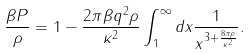<formula> <loc_0><loc_0><loc_500><loc_500>\frac { \beta P } { \rho } = 1 - \frac { 2 \pi \beta q ^ { 2 } \rho } { \kappa ^ { 2 } } \int _ { 1 } ^ { \infty } d x \frac { 1 } { x ^ { 3 + \frac { 8 \pi \rho } { \kappa ^ { 2 } } } } .</formula> 